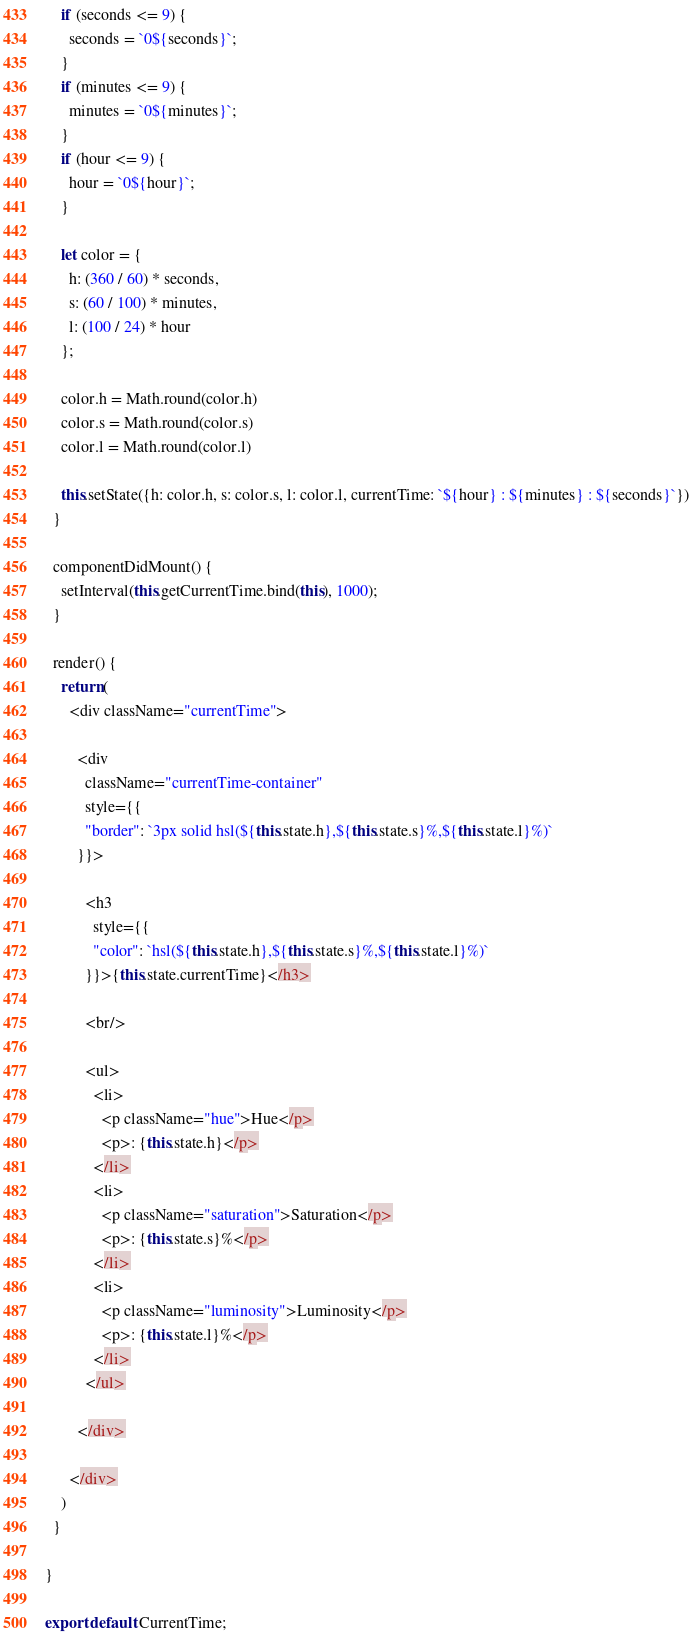Convert code to text. <code><loc_0><loc_0><loc_500><loc_500><_JavaScript_>    if (seconds <= 9) {
      seconds = `0${seconds}`;
    }
    if (minutes <= 9) {
      minutes = `0${minutes}`;
    }
    if (hour <= 9) {
      hour = `0${hour}`;
    }

    let color = {
      h: (360 / 60) * seconds,
      s: (60 / 100) * minutes,
      l: (100 / 24) * hour
    };

    color.h = Math.round(color.h)
    color.s = Math.round(color.s)
    color.l = Math.round(color.l)

    this.setState({h: color.h, s: color.s, l: color.l, currentTime: `${hour} : ${minutes} : ${seconds}`})
  }

  componentDidMount() {
    setInterval(this.getCurrentTime.bind(this), 1000);
  }

  render() {
    return (
      <div className="currentTime">

        <div
          className="currentTime-container"
          style={{
          "border": `3px solid hsl(${this.state.h},${this.state.s}%,${this.state.l}%)`
        }}>

          <h3
            style={{
            "color": `hsl(${this.state.h},${this.state.s}%,${this.state.l}%)`
          }}>{this.state.currentTime}</h3>

          <br/>

          <ul>
            <li>
              <p className="hue">Hue</p>
              <p>: {this.state.h}</p>
            </li>
            <li>
              <p className="saturation">Saturation</p>
              <p>: {this.state.s}%</p>
            </li>
            <li>
              <p className="luminosity">Luminosity</p>
              <p>: {this.state.l}%</p>
            </li>
          </ul>

        </div>

      </div>
    )
  }

}

export default CurrentTime;</code> 